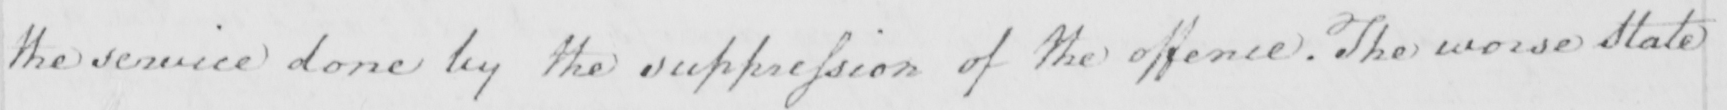Can you tell me what this handwritten text says? the service done by the suppression of the offence . the worse State 